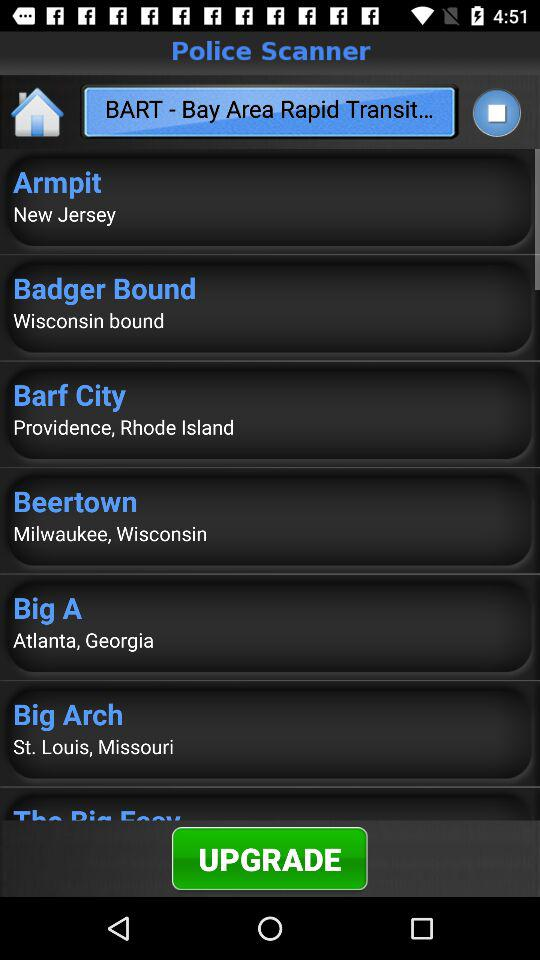What is the name of the application? The name of the application is "Police Scanner". 